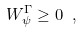<formula> <loc_0><loc_0><loc_500><loc_500>W _ { \psi } ^ { \Gamma } \geq 0 \ ,</formula> 